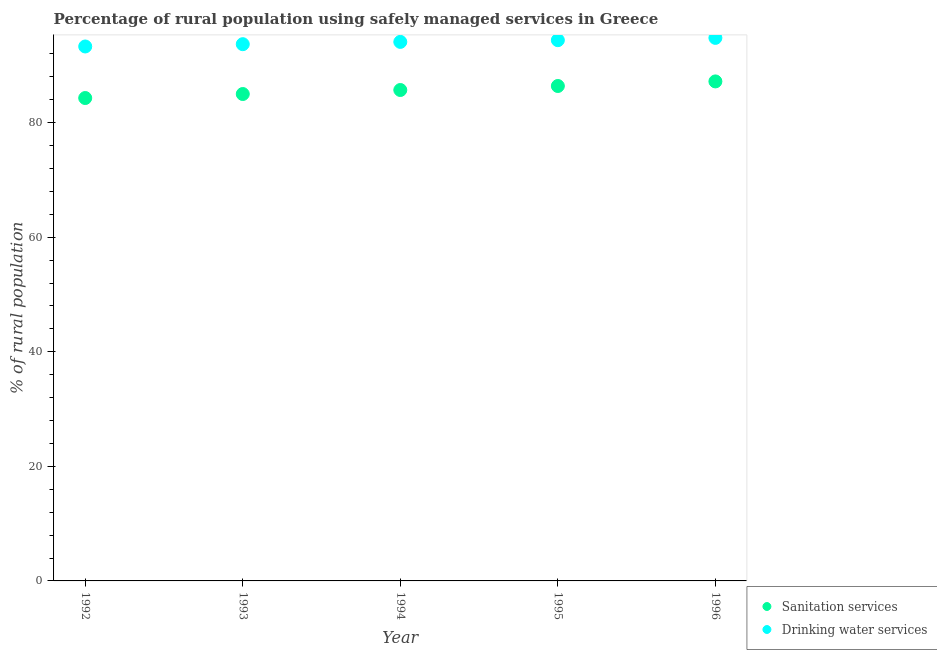How many different coloured dotlines are there?
Make the answer very short. 2. What is the percentage of rural population who used drinking water services in 1996?
Your answer should be compact. 94.8. Across all years, what is the maximum percentage of rural population who used sanitation services?
Keep it short and to the point. 87.2. Across all years, what is the minimum percentage of rural population who used sanitation services?
Your answer should be very brief. 84.3. What is the total percentage of rural population who used sanitation services in the graph?
Offer a terse response. 428.6. What is the difference between the percentage of rural population who used drinking water services in 1992 and that in 1996?
Provide a succinct answer. -1.5. What is the difference between the percentage of rural population who used sanitation services in 1994 and the percentage of rural population who used drinking water services in 1995?
Provide a succinct answer. -8.7. What is the average percentage of rural population who used drinking water services per year?
Keep it short and to the point. 94.06. In the year 1992, what is the difference between the percentage of rural population who used drinking water services and percentage of rural population who used sanitation services?
Offer a very short reply. 9. In how many years, is the percentage of rural population who used drinking water services greater than 16 %?
Provide a short and direct response. 5. What is the ratio of the percentage of rural population who used drinking water services in 1993 to that in 1995?
Give a very brief answer. 0.99. Is the percentage of rural population who used sanitation services in 1992 less than that in 1994?
Ensure brevity in your answer.  Yes. Is the difference between the percentage of rural population who used sanitation services in 1993 and 1994 greater than the difference between the percentage of rural population who used drinking water services in 1993 and 1994?
Provide a short and direct response. No. What is the difference between the highest and the second highest percentage of rural population who used drinking water services?
Give a very brief answer. 0.4. Is the percentage of rural population who used drinking water services strictly greater than the percentage of rural population who used sanitation services over the years?
Offer a very short reply. Yes. Is the percentage of rural population who used drinking water services strictly less than the percentage of rural population who used sanitation services over the years?
Your answer should be very brief. No. Does the graph contain any zero values?
Offer a terse response. No. Where does the legend appear in the graph?
Make the answer very short. Bottom right. How many legend labels are there?
Give a very brief answer. 2. What is the title of the graph?
Provide a short and direct response. Percentage of rural population using safely managed services in Greece. What is the label or title of the Y-axis?
Keep it short and to the point. % of rural population. What is the % of rural population of Sanitation services in 1992?
Offer a terse response. 84.3. What is the % of rural population in Drinking water services in 1992?
Your response must be concise. 93.3. What is the % of rural population of Sanitation services in 1993?
Make the answer very short. 85. What is the % of rural population in Drinking water services in 1993?
Provide a short and direct response. 93.7. What is the % of rural population in Sanitation services in 1994?
Keep it short and to the point. 85.7. What is the % of rural population of Drinking water services in 1994?
Provide a short and direct response. 94.1. What is the % of rural population of Sanitation services in 1995?
Make the answer very short. 86.4. What is the % of rural population in Drinking water services in 1995?
Provide a succinct answer. 94.4. What is the % of rural population of Sanitation services in 1996?
Provide a succinct answer. 87.2. What is the % of rural population in Drinking water services in 1996?
Your answer should be compact. 94.8. Across all years, what is the maximum % of rural population of Sanitation services?
Your answer should be compact. 87.2. Across all years, what is the maximum % of rural population in Drinking water services?
Make the answer very short. 94.8. Across all years, what is the minimum % of rural population in Sanitation services?
Offer a terse response. 84.3. Across all years, what is the minimum % of rural population in Drinking water services?
Make the answer very short. 93.3. What is the total % of rural population in Sanitation services in the graph?
Your answer should be very brief. 428.6. What is the total % of rural population of Drinking water services in the graph?
Offer a terse response. 470.3. What is the difference between the % of rural population of Sanitation services in 1992 and that in 1993?
Keep it short and to the point. -0.7. What is the difference between the % of rural population of Drinking water services in 1992 and that in 1993?
Provide a short and direct response. -0.4. What is the difference between the % of rural population of Drinking water services in 1992 and that in 1994?
Keep it short and to the point. -0.8. What is the difference between the % of rural population in Sanitation services in 1993 and that in 1994?
Keep it short and to the point. -0.7. What is the difference between the % of rural population in Sanitation services in 1993 and that in 1996?
Keep it short and to the point. -2.2. What is the difference between the % of rural population in Sanitation services in 1994 and that in 1995?
Provide a succinct answer. -0.7. What is the difference between the % of rural population of Drinking water services in 1994 and that in 1995?
Give a very brief answer. -0.3. What is the difference between the % of rural population of Sanitation services in 1994 and that in 1996?
Keep it short and to the point. -1.5. What is the difference between the % of rural population of Drinking water services in 1994 and that in 1996?
Keep it short and to the point. -0.7. What is the difference between the % of rural population in Sanitation services in 1995 and that in 1996?
Keep it short and to the point. -0.8. What is the difference between the % of rural population of Drinking water services in 1995 and that in 1996?
Your answer should be very brief. -0.4. What is the difference between the % of rural population in Sanitation services in 1992 and the % of rural population in Drinking water services in 1993?
Give a very brief answer. -9.4. What is the difference between the % of rural population in Sanitation services in 1992 and the % of rural population in Drinking water services in 1995?
Make the answer very short. -10.1. What is the difference between the % of rural population in Sanitation services in 1993 and the % of rural population in Drinking water services in 1996?
Offer a terse response. -9.8. What is the average % of rural population of Sanitation services per year?
Your response must be concise. 85.72. What is the average % of rural population of Drinking water services per year?
Give a very brief answer. 94.06. In the year 1992, what is the difference between the % of rural population in Sanitation services and % of rural population in Drinking water services?
Give a very brief answer. -9. In the year 1994, what is the difference between the % of rural population of Sanitation services and % of rural population of Drinking water services?
Give a very brief answer. -8.4. In the year 1995, what is the difference between the % of rural population in Sanitation services and % of rural population in Drinking water services?
Your response must be concise. -8. In the year 1996, what is the difference between the % of rural population in Sanitation services and % of rural population in Drinking water services?
Provide a short and direct response. -7.6. What is the ratio of the % of rural population in Sanitation services in 1992 to that in 1994?
Give a very brief answer. 0.98. What is the ratio of the % of rural population in Sanitation services in 1992 to that in 1995?
Offer a terse response. 0.98. What is the ratio of the % of rural population of Drinking water services in 1992 to that in 1995?
Make the answer very short. 0.99. What is the ratio of the % of rural population of Sanitation services in 1992 to that in 1996?
Your answer should be compact. 0.97. What is the ratio of the % of rural population of Drinking water services in 1992 to that in 1996?
Make the answer very short. 0.98. What is the ratio of the % of rural population of Sanitation services in 1993 to that in 1994?
Your answer should be compact. 0.99. What is the ratio of the % of rural population of Drinking water services in 1993 to that in 1994?
Make the answer very short. 1. What is the ratio of the % of rural population of Sanitation services in 1993 to that in 1995?
Give a very brief answer. 0.98. What is the ratio of the % of rural population in Drinking water services in 1993 to that in 1995?
Make the answer very short. 0.99. What is the ratio of the % of rural population in Sanitation services in 1993 to that in 1996?
Your answer should be compact. 0.97. What is the ratio of the % of rural population in Drinking water services in 1993 to that in 1996?
Your answer should be very brief. 0.99. What is the ratio of the % of rural population of Sanitation services in 1994 to that in 1995?
Offer a terse response. 0.99. What is the ratio of the % of rural population of Sanitation services in 1994 to that in 1996?
Ensure brevity in your answer.  0.98. What is the ratio of the % of rural population of Drinking water services in 1995 to that in 1996?
Give a very brief answer. 1. 